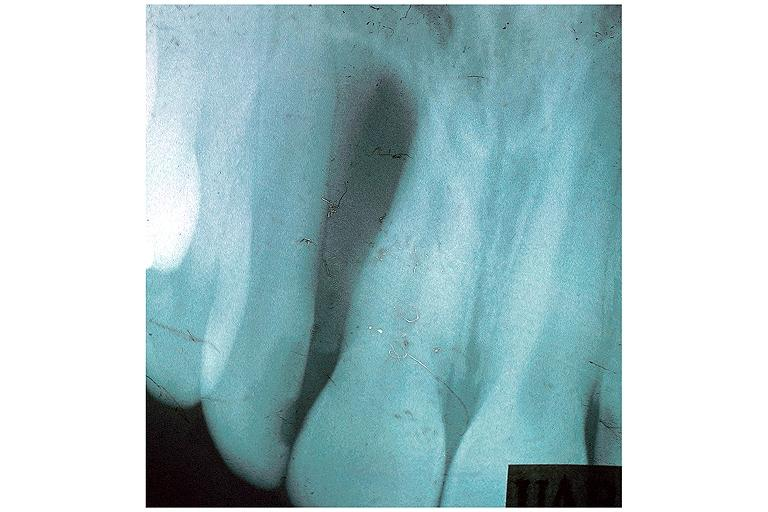s leiomyoma present?
Answer the question using a single word or phrase. No 